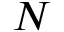Convert formula to latex. <formula><loc_0><loc_0><loc_500><loc_500>N</formula> 